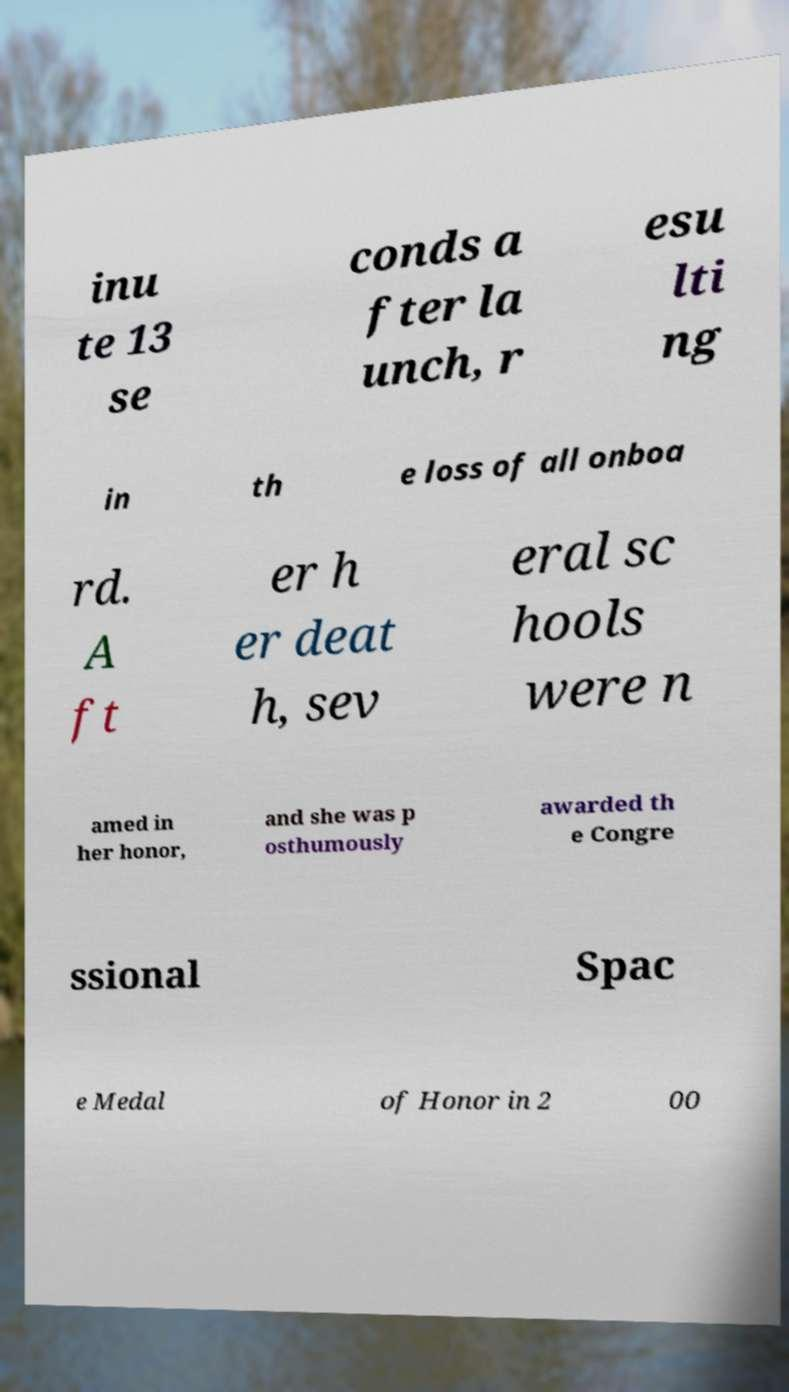Please read and relay the text visible in this image. What does it say? inu te 13 se conds a fter la unch, r esu lti ng in th e loss of all onboa rd. A ft er h er deat h, sev eral sc hools were n amed in her honor, and she was p osthumously awarded th e Congre ssional Spac e Medal of Honor in 2 00 